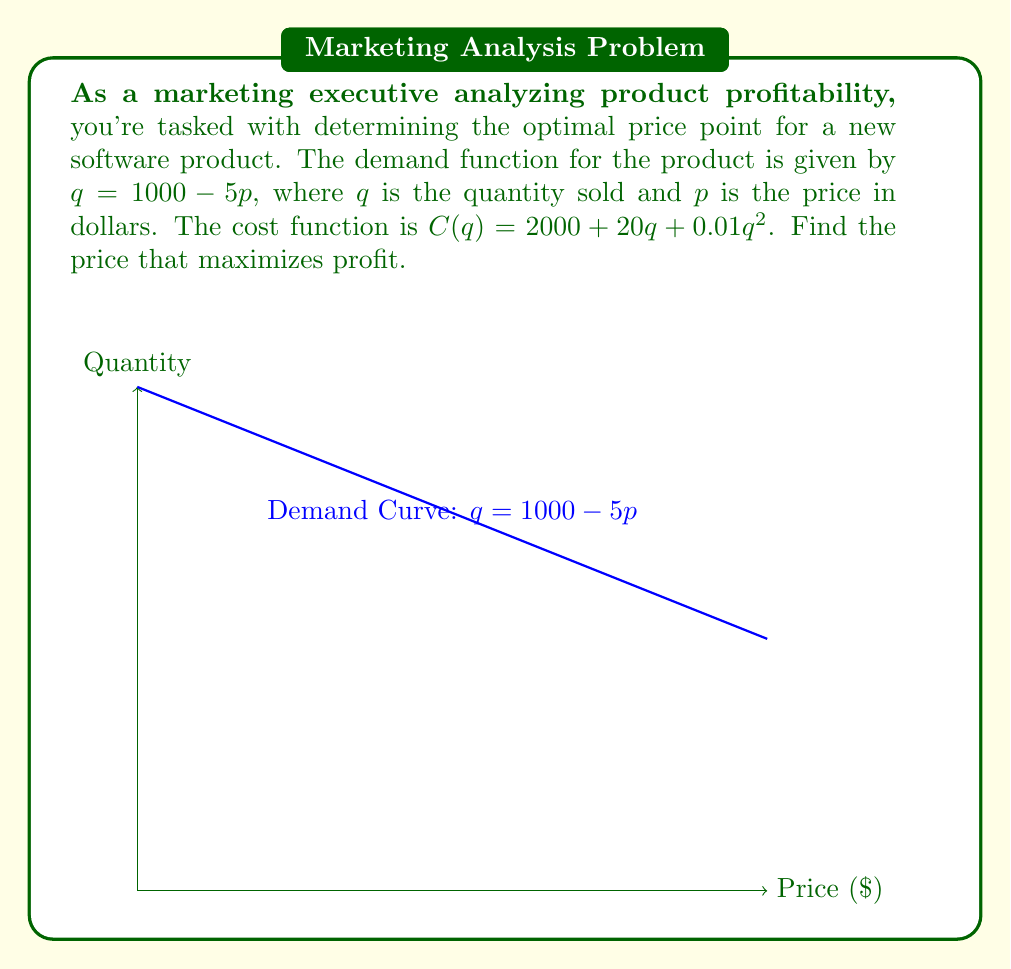Could you help me with this problem? Let's approach this step-by-step:

1) First, we need to express the profit function in terms of p:
   Profit = Revenue - Cost
   $\Pi(p) = pq - C(q)$

2) Substitute $q = 1000 - 5p$ into the profit function:
   $\Pi(p) = p(1000-5p) - [2000 + 20(1000-5p) + 0.01(1000-5p)^2]$

3) Expand the equation:
   $\Pi(p) = 1000p - 5p^2 - 2000 - 20000 + 100p - 10000 + 100p - 0.25p^2$
   $\Pi(p) = -5.25p^2 + 1200p - 32000$

4) To find the maximum profit, we need to find where the derivative of the profit function equals zero:
   $\frac{d\Pi}{dp} = -10.5p + 1200 = 0$

5) Solve for p:
   $-10.5p = -1200$
   $p = \frac{1200}{10.5} \approx 114.29$

6) To confirm this is a maximum, check the second derivative:
   $\frac{d^2\Pi}{dp^2} = -10.5 < 0$, confirming a maximum.

7) Therefore, the profit-maximizing price is approximately $114.29.
Answer: $114.29 